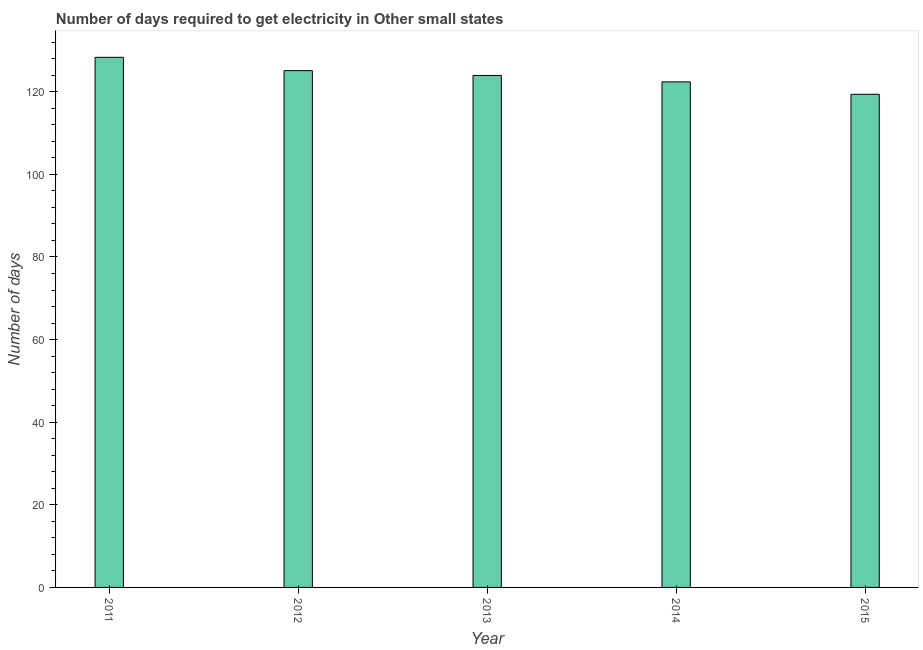Does the graph contain grids?
Offer a terse response. No. What is the title of the graph?
Make the answer very short. Number of days required to get electricity in Other small states. What is the label or title of the X-axis?
Your answer should be compact. Year. What is the label or title of the Y-axis?
Your answer should be very brief. Number of days. What is the time to get electricity in 2012?
Your answer should be compact. 125.11. Across all years, what is the maximum time to get electricity?
Your answer should be compact. 128.33. Across all years, what is the minimum time to get electricity?
Provide a succinct answer. 119.39. In which year was the time to get electricity minimum?
Ensure brevity in your answer.  2015. What is the sum of the time to get electricity?
Offer a very short reply. 619.17. What is the difference between the time to get electricity in 2011 and 2015?
Offer a very short reply. 8.94. What is the average time to get electricity per year?
Your answer should be compact. 123.83. What is the median time to get electricity?
Keep it short and to the point. 123.94. In how many years, is the time to get electricity greater than 72 ?
Provide a succinct answer. 5. Do a majority of the years between 2014 and 2013 (inclusive) have time to get electricity greater than 12 ?
Offer a terse response. No. What is the ratio of the time to get electricity in 2012 to that in 2015?
Offer a very short reply. 1.05. Is the time to get electricity in 2011 less than that in 2014?
Give a very brief answer. No. Is the difference between the time to get electricity in 2011 and 2014 greater than the difference between any two years?
Offer a very short reply. No. What is the difference between the highest and the second highest time to get electricity?
Your answer should be very brief. 3.22. What is the difference between the highest and the lowest time to get electricity?
Your answer should be compact. 8.94. In how many years, is the time to get electricity greater than the average time to get electricity taken over all years?
Ensure brevity in your answer.  3. Are all the bars in the graph horizontal?
Offer a very short reply. No. What is the difference between two consecutive major ticks on the Y-axis?
Make the answer very short. 20. What is the Number of days in 2011?
Offer a very short reply. 128.33. What is the Number of days of 2012?
Your answer should be compact. 125.11. What is the Number of days of 2013?
Provide a succinct answer. 123.94. What is the Number of days of 2014?
Make the answer very short. 122.39. What is the Number of days of 2015?
Your answer should be compact. 119.39. What is the difference between the Number of days in 2011 and 2012?
Make the answer very short. 3.22. What is the difference between the Number of days in 2011 and 2013?
Give a very brief answer. 4.39. What is the difference between the Number of days in 2011 and 2014?
Offer a very short reply. 5.94. What is the difference between the Number of days in 2011 and 2015?
Ensure brevity in your answer.  8.94. What is the difference between the Number of days in 2012 and 2013?
Your answer should be very brief. 1.17. What is the difference between the Number of days in 2012 and 2014?
Make the answer very short. 2.72. What is the difference between the Number of days in 2012 and 2015?
Your response must be concise. 5.72. What is the difference between the Number of days in 2013 and 2014?
Give a very brief answer. 1.56. What is the difference between the Number of days in 2013 and 2015?
Make the answer very short. 4.56. What is the difference between the Number of days in 2014 and 2015?
Provide a succinct answer. 3. What is the ratio of the Number of days in 2011 to that in 2012?
Make the answer very short. 1.03. What is the ratio of the Number of days in 2011 to that in 2013?
Ensure brevity in your answer.  1.03. What is the ratio of the Number of days in 2011 to that in 2014?
Keep it short and to the point. 1.05. What is the ratio of the Number of days in 2011 to that in 2015?
Keep it short and to the point. 1.07. What is the ratio of the Number of days in 2012 to that in 2014?
Your answer should be very brief. 1.02. What is the ratio of the Number of days in 2012 to that in 2015?
Your answer should be very brief. 1.05. What is the ratio of the Number of days in 2013 to that in 2014?
Your answer should be compact. 1.01. What is the ratio of the Number of days in 2013 to that in 2015?
Your answer should be very brief. 1.04. What is the ratio of the Number of days in 2014 to that in 2015?
Your answer should be compact. 1.02. 